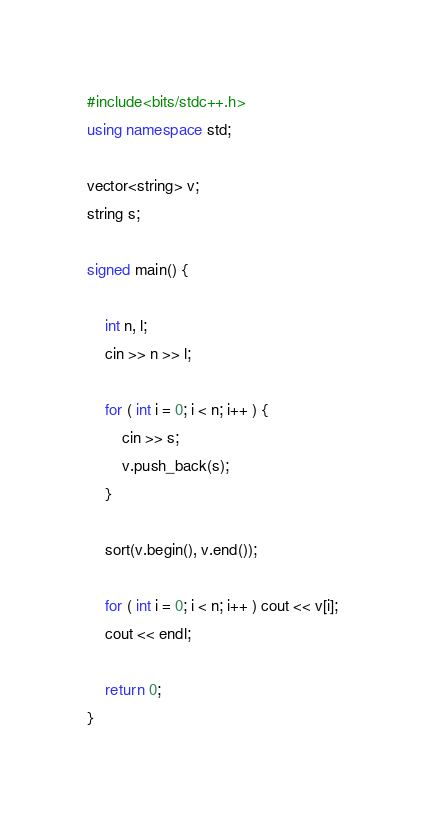<code> <loc_0><loc_0><loc_500><loc_500><_C++_>#include<bits/stdc++.h>
using namespace std;

vector<string> v;
string s;

signed main() {

    int n, l;
    cin >> n >> l;

    for ( int i = 0; i < n; i++ ) {
        cin >> s;
        v.push_back(s);
    }

    sort(v.begin(), v.end());

    for ( int i = 0; i < n; i++ ) cout << v[i];
    cout << endl;

    return 0;
}</code> 